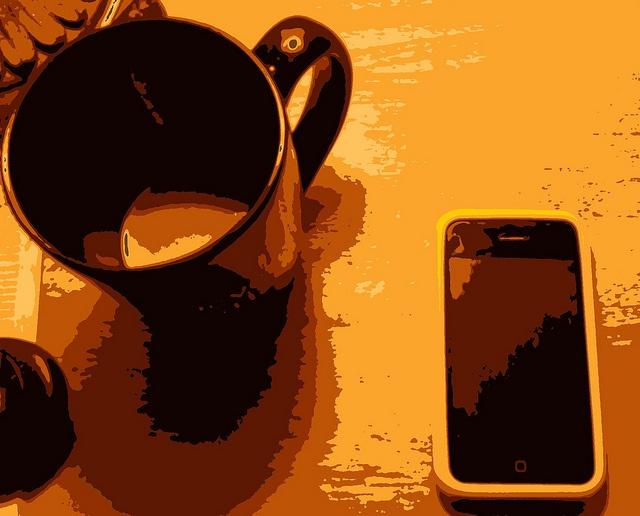Describe the objects in this image and their specific colors. I can see dining table in maroon, orange, red, and black tones, cup in maroon, black, and red tones, and cell phone in maroon, black, orange, and red tones in this image. 